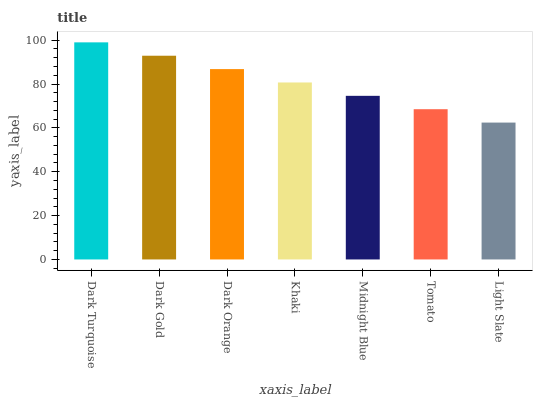Is Light Slate the minimum?
Answer yes or no. Yes. Is Dark Turquoise the maximum?
Answer yes or no. Yes. Is Dark Gold the minimum?
Answer yes or no. No. Is Dark Gold the maximum?
Answer yes or no. No. Is Dark Turquoise greater than Dark Gold?
Answer yes or no. Yes. Is Dark Gold less than Dark Turquoise?
Answer yes or no. Yes. Is Dark Gold greater than Dark Turquoise?
Answer yes or no. No. Is Dark Turquoise less than Dark Gold?
Answer yes or no. No. Is Khaki the high median?
Answer yes or no. Yes. Is Khaki the low median?
Answer yes or no. Yes. Is Midnight Blue the high median?
Answer yes or no. No. Is Midnight Blue the low median?
Answer yes or no. No. 